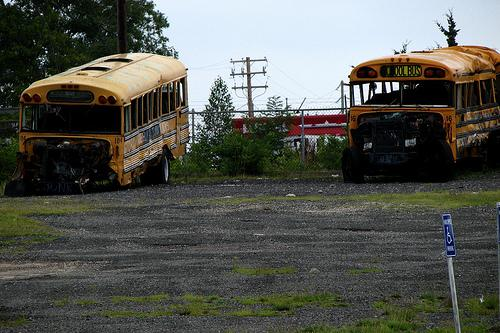Explain the condition of the ground in the image. The ground is a gravelly parking lot with patches of grass and dirt growing through the asphalt surface. Describe the state of the school buses in the image. The school buses are broken down, dented, and damaged, with missing front wheels, smashed front ends, and missing windows. Identify the main objects in the image and their conditions. Two broken down school buses, one yellow and one orange, with missing front wheels and windows, handicapped parking sign, chain link fence, metal and wooden utility poles, and red building with a red roof. Assess the image quality in terms of its ability to portray the objects and their details. The image quality is sufficient to clearly portray the objects, their details, and their conditions, allowing for analysis of the damaged school buses and their surroundings. What type of signage is included in the image and what does it represent? A blue and white handicapped parking sign is included in the image, representing a reserved parking area for individuals with disabilities. List the different types of poles and their respective features present in the image. There is a tall wooden electrical post with wires, a silver sign post for the handicapped sign, and a multi utility pole holding wires. Describe the general sentiments that this image invokes. The image invokes feelings of abandonment, disrepair, neglect, and sadness due to the broken down and damaged school buses, the overgrowth, and the overall desolate setting. Count the total number of buses and poles in the image. There are two buses and three poles in the image. Analyze the interaction between the two school buses and their surroundings. The two school buses are left abandoned in a neglected parking lot, surrounded by a chain link fence and overgrown grass. They seem to have been there for quite some time as they are damaged and missing some parts. How many school buses are present in the image and what are their colors? There are two school buses, one is yellow and the other one is orange. Can you detect any ongoing event in the image? No Write a sentence that describes the scene featuring the two broken school buses. Two broken yellow school buses are parked in a gravelly lot with grass growing through the pavement, separated by a chain link fence and surrounded by various objects such as signs, utility poles, and a red building in the background. Describe the appearance of the utility pole in the image. Tall wooden electrical post with multiple wires attached. Is there a bright red fire hydrant next to the utility pole in the distance? The image doesn't have a fire hydrant, but the question can lead to someone inspecting the image to ensure they didn't miss it. What kind of event can be detected in this image? Abandoned school buses Identify the numbers displayed on the two buses. 46 and 104 Notice the playful dog near the fence, it seems to be having a great time. The image has no dog, but mentioning a playful dog near the fence may make someone look closely for it. Explain the layout of the scene in a diagrammatic way. Two broken yellow school buses are situated side by side in a gravelly lot, separated by a chain link fence, and featuring signs, utility poles, and a red building in the background. Explain how the vegetation in the image impacts the overall scene. Grass growing through the pavement and small trees and bushes behind the fence contribute to the abandoned and overgrown appearance of the scene. What color is the sign indicating handicapped parking? Blue and white What is the current state of the school buses? Abandoned and damaged Is the pole holding the handicapped sign made of wood or metal? Metal Create a short story about the broken down school buses in the image. In an abandoned parking lot, two worn-down yellow school buses stood silently side by side. The rusting hulks, separated by a chain-link fence, bore witness to nature slowly reclaiming the area. A red building looked on in the distance, while a blue and white handicapped sign rusted nearby. What's the condition of the buses in the image? Broken down and damaged Can you find the green car parked between the two broken buses? There's no green car in the image, but the mention of the buses might make one look closely for a non-existent car between them. Describe the activity taking place in the image involving the buses. The buses are broken and not in use. Describe the handicapped sign and pole in the image. A blue and white handicapped sign is attached to a silver pole near the broken buses. A group of people can be seen discussing something behind the red building. The image does not include any people, but the reference to discussions behind the red building might attract extra attention to that area. Which bus is missing both front tires? The bus on the left The shiny silver bicycle leaning against the fence looks brand-new, doesn't it? There is no bicycle in the image, but mentioning a shiny new one can make someone look for it near the fence. Read the text on the handicapped parking sign. Handicapped parking Provide a poetic description of the scene with the two broken buses. Amidst a desolate lot of worn gravel and pavement sprouting grass, two forsaken yellow school buses sigh side by side, enrobed in damage and rust, as a vigilant red building and signs keep watch. Do you think the graffiti on the gravelly parking lot adds to the overall atmosphere? There is no graffiti in the image, but the question can make the reader search for it and even contemplate its artistic value. Create a haiku about the scene featuring the two broken school buses. Yellow giants rest 